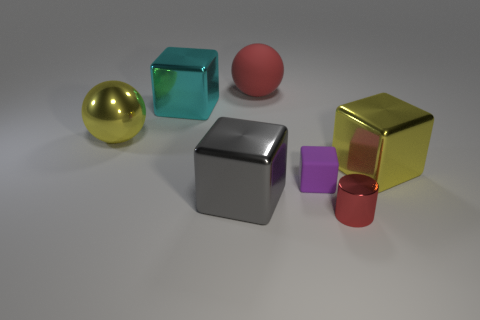Subtract all big yellow metal cubes. How many cubes are left? 3 Add 1 small metallic objects. How many objects exist? 8 Add 6 yellow cubes. How many yellow cubes exist? 7 Subtract all yellow blocks. How many blocks are left? 3 Subtract 1 gray cubes. How many objects are left? 6 Subtract all cylinders. How many objects are left? 6 Subtract 1 cylinders. How many cylinders are left? 0 Subtract all red cubes. Subtract all yellow balls. How many cubes are left? 4 Subtract all purple cylinders. How many purple balls are left? 0 Subtract all tiny yellow spheres. Subtract all cylinders. How many objects are left? 6 